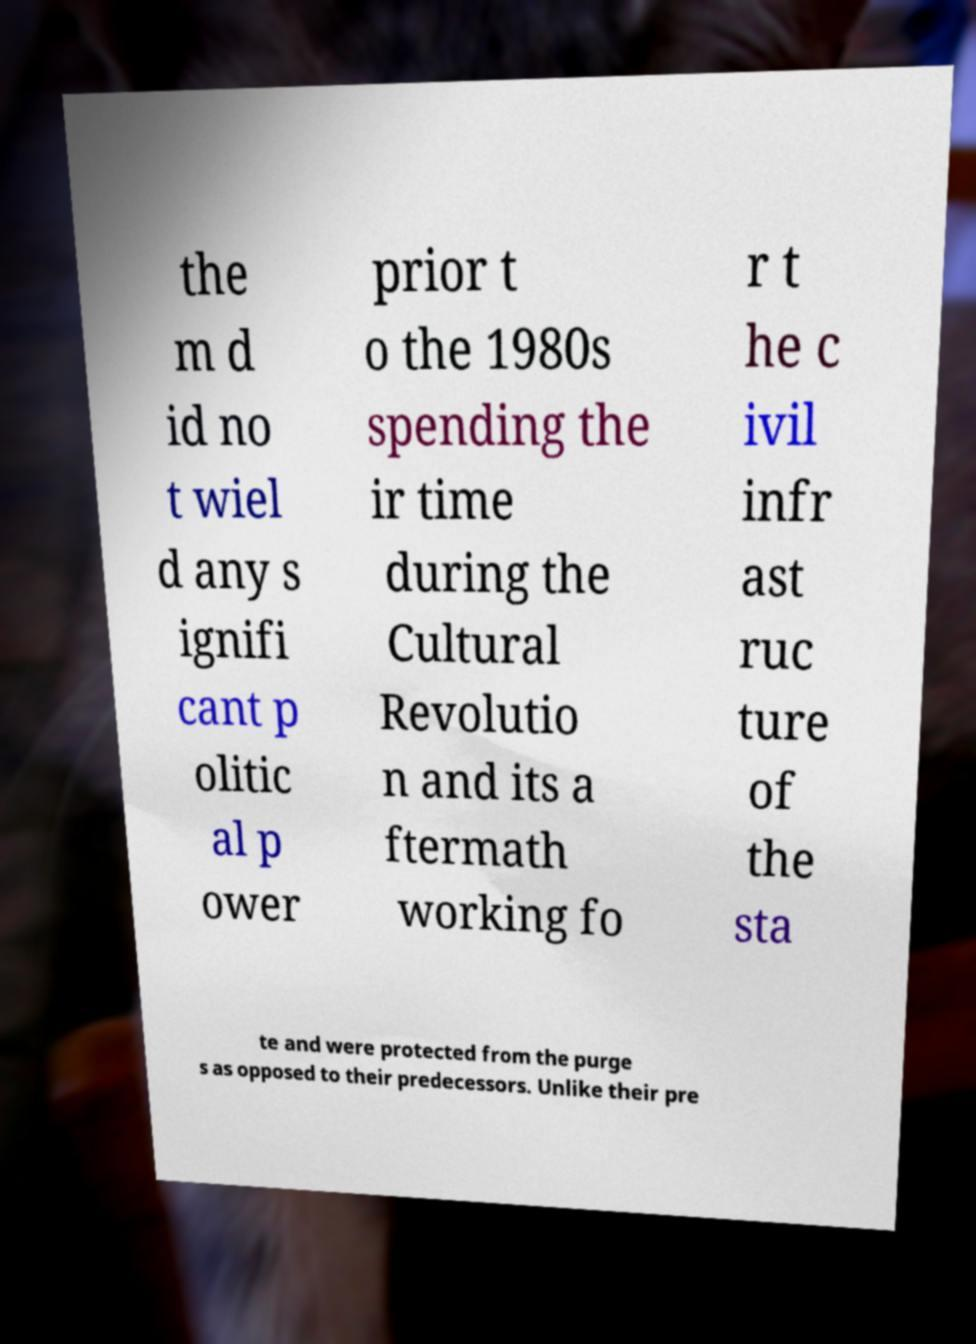For documentation purposes, I need the text within this image transcribed. Could you provide that? the m d id no t wiel d any s ignifi cant p olitic al p ower prior t o the 1980s spending the ir time during the Cultural Revolutio n and its a ftermath working fo r t he c ivil infr ast ruc ture of the sta te and were protected from the purge s as opposed to their predecessors. Unlike their pre 